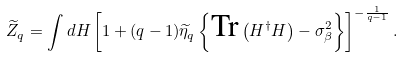<formula> <loc_0><loc_0><loc_500><loc_500>\widetilde { Z } _ { q } = \int d H \left [ 1 + ( q - 1 ) \widetilde { \eta } _ { q } \left \{ \text {Tr} \left ( H ^ { \dagger } H \right ) - \sigma _ { \beta } ^ { 2 } \right \} \right ] ^ { - \frac { 1 } { q - 1 } } .</formula> 